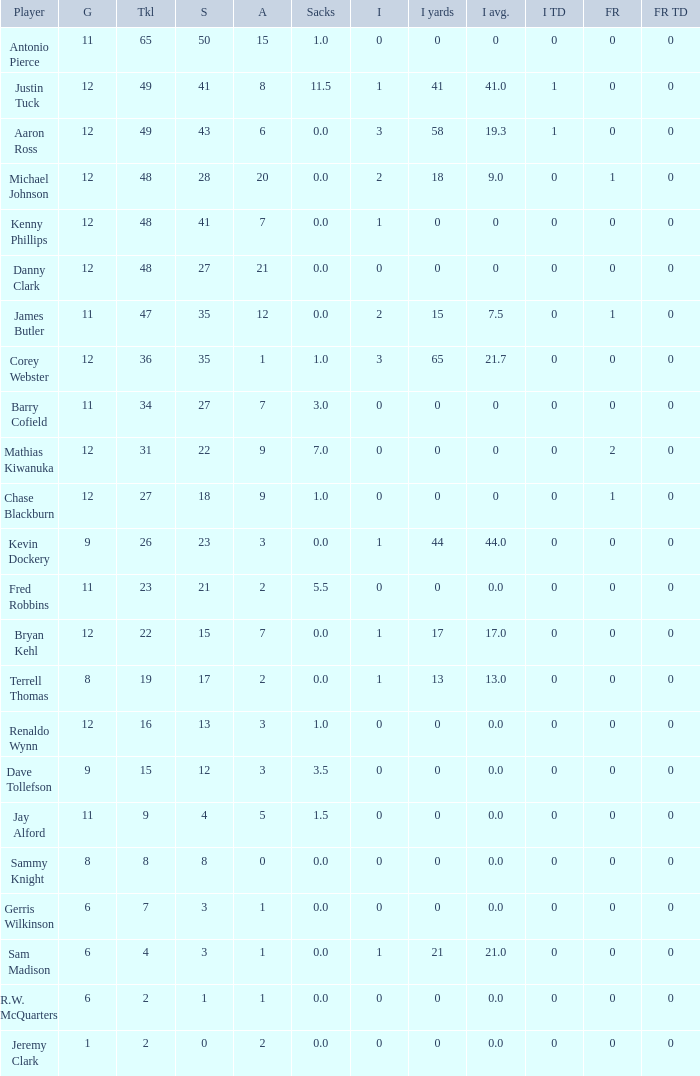Name the least amount of int yards 0.0. 